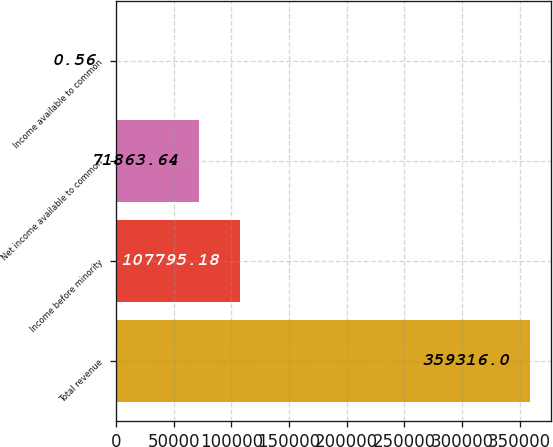<chart> <loc_0><loc_0><loc_500><loc_500><bar_chart><fcel>Total revenue<fcel>Income before minority<fcel>Net income available to common<fcel>Income available to common<nl><fcel>359316<fcel>107795<fcel>71863.6<fcel>0.56<nl></chart> 